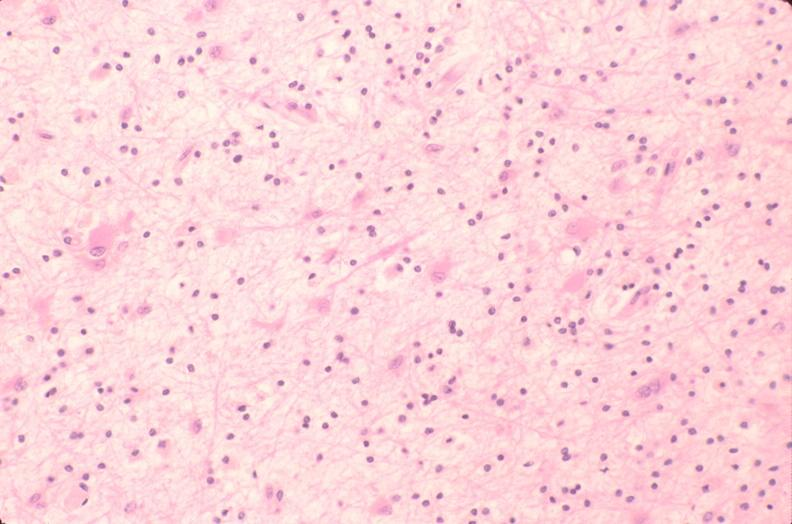where is this?
Answer the question using a single word or phrase. Nervous 